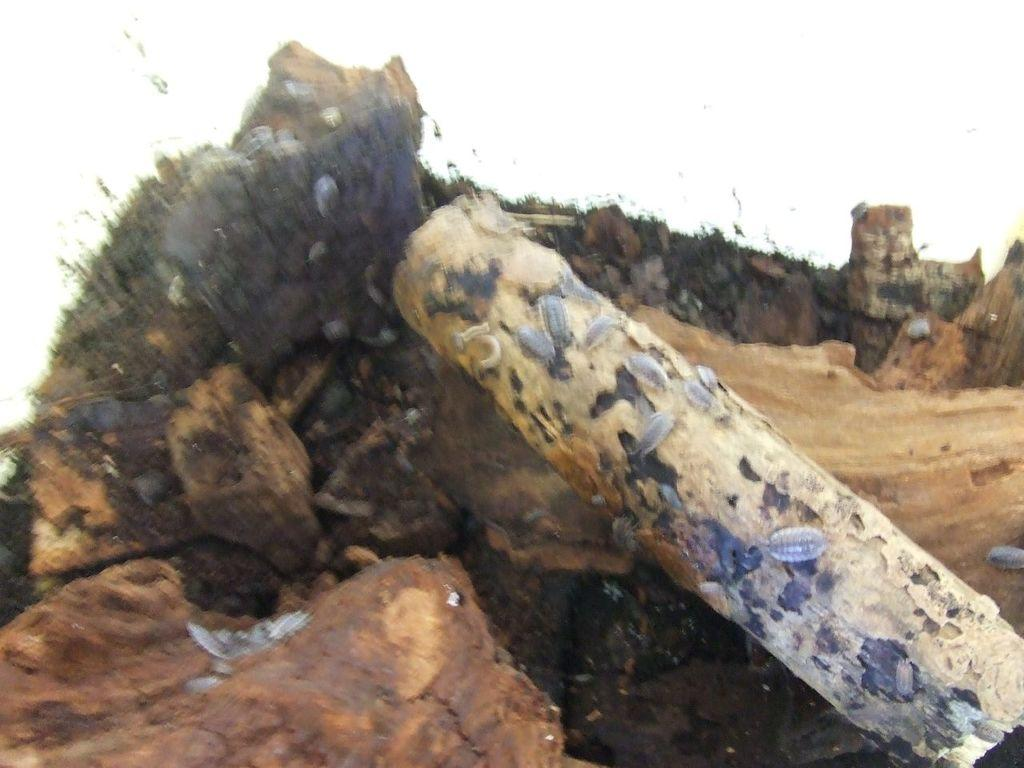What is the main feature in the center of the image? There is a hill in the center of the image. Is there anything on the hill? Yes, a stone is present on the hill. What can be seen on the stone? Insects are visible on the stone. What is visible at the top of the image? The sky is present at the top of the image. What is the interest rate on the grandfather's loan in the image? There is no mention of a loan or a grandfather in the image, so it is impossible to determine the interest rate. 